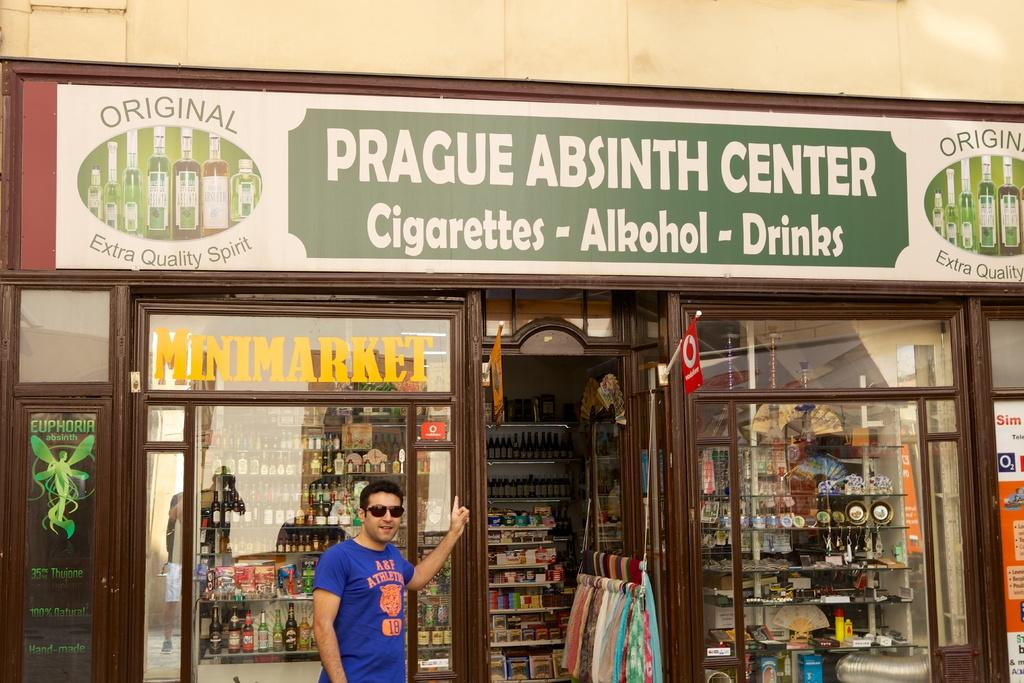<image>
Share a concise interpretation of the image provided. A man stands outside the Prague Absinth Center. 